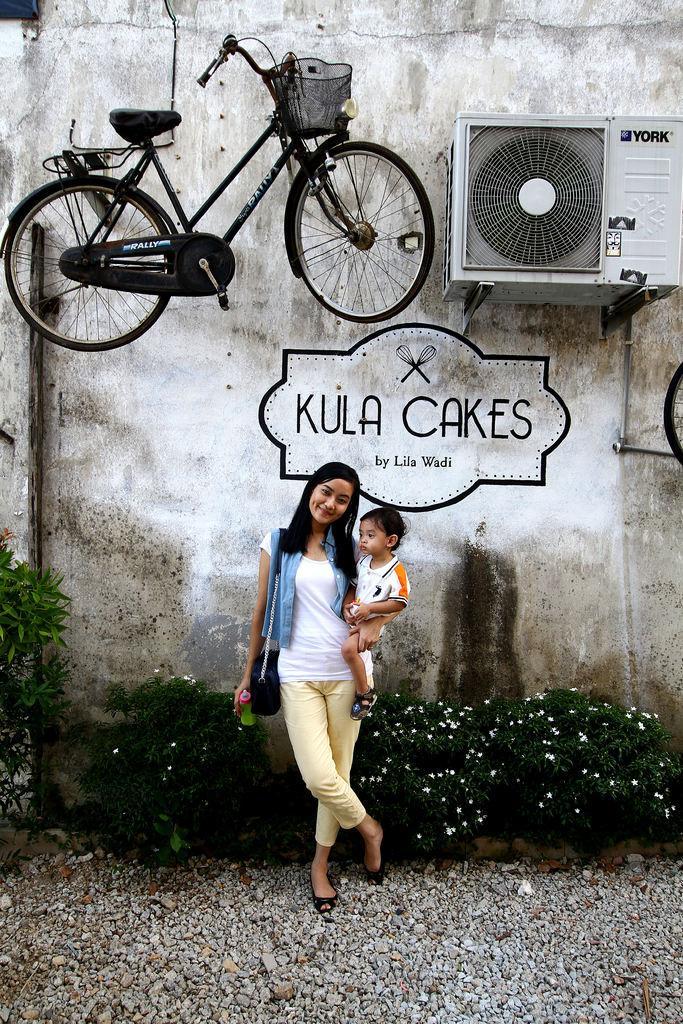How would you summarize this image in a sentence or two? In this image at front there is a woman standing on the surface of the stones by holding the baby and a bottle. On the backside there is a wall with the painting on it. We can see a cycle and an AC attached to the wall. 